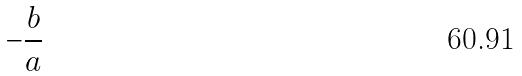Convert formula to latex. <formula><loc_0><loc_0><loc_500><loc_500>- \frac { b } { a }</formula> 